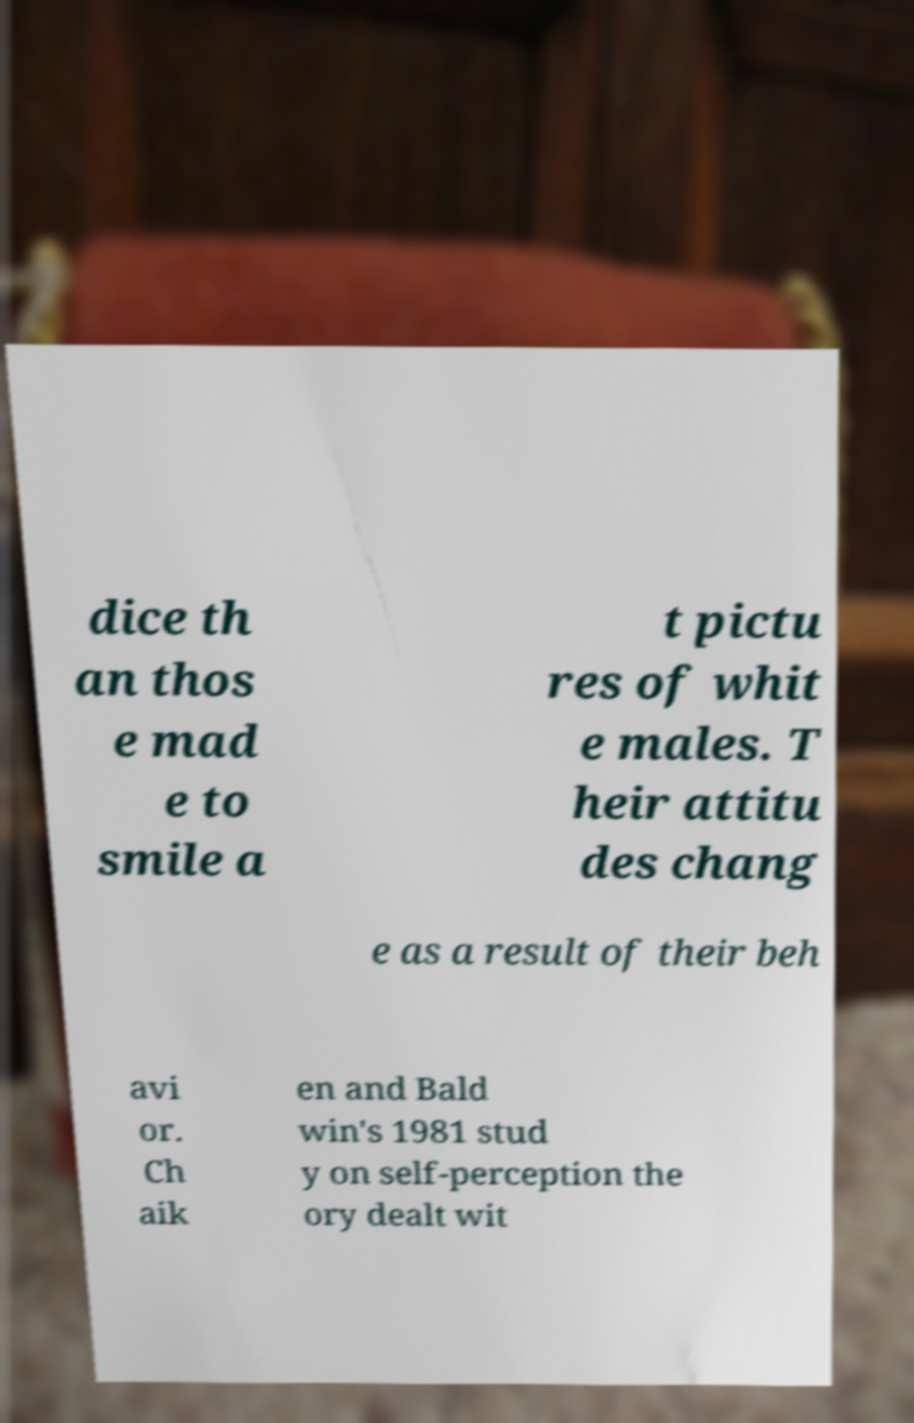Please identify and transcribe the text found in this image. dice th an thos e mad e to smile a t pictu res of whit e males. T heir attitu des chang e as a result of their beh avi or. Ch aik en and Bald win's 1981 stud y on self-perception the ory dealt wit 